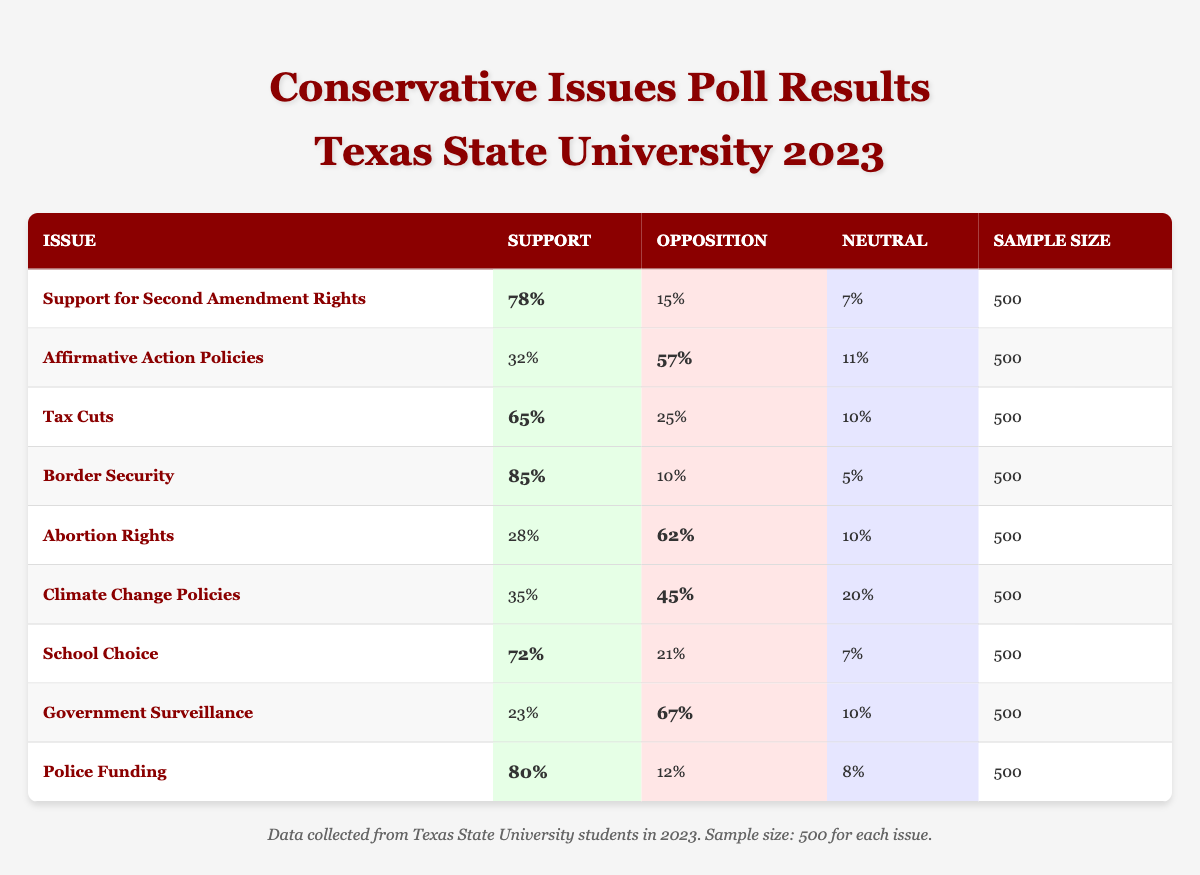What percentage of Texas State University students support Border Security? The table lists a support percentage of 85% for Border Security, which is clearly stated under the "Support" column next to the corresponding issue.
Answer: 85% What is the sample size for all issues in the poll? The sample size for each issue is consistently noted as 500 in the table.
Answer: 500 Which issue has the highest opposition percentage among the listed topics? When examining the "Opposition" column, the highest percentage is 67% for Government Surveillance, which is greater than the oppositions of other issues.
Answer: Government Surveillance What is the percentage difference between support and opposition for Tax Cuts? The support for Tax Cuts is 65%, and the opposition is 25%. The difference is calculated as 65% - 25% = 40%.
Answer: 40% Is there a majority support for School Choice among Texas State University students? The support percentage for School Choice is 72%, which is greater than 50%, indicating a majority support.
Answer: Yes What is the average support percentage for the issues related to education (School Choice and Affirmative Action Policies)? The support percentages for School Choice and Affirmative Action Policies are 72% and 32%, respectively. The average is calculated as (72% + 32%) / 2 = 52%.
Answer: 52% How many issues have more than 75% support among Texas State University students? The issues with support exceeding 75% are Support for Second Amendment Rights (78%), Border Security (85%), and Police Funding (80%). That makes a total of three issues.
Answer: 3 What percentage of respondents were neutral on Climate Change Policies? The table states that 20% of respondents indicated a neutral position regarding Climate Change Policies, which can be directly referred to in the "Neutral" column.
Answer: 20% Which issue demonstrates the least support among Texas State University students? Analyzing the "Support" column, Abortion Rights shows the lowest support at 28% compared to the other issues listed.
Answer: Abortion Rights What total percentage of students expressed opposition to School Choice and Affirmative Action Policies combined? Adding the opposition percentages for School Choice (21%) and Affirmative Action Policies (57%) gives a total of 21% + 57% = 78%.
Answer: 78% 